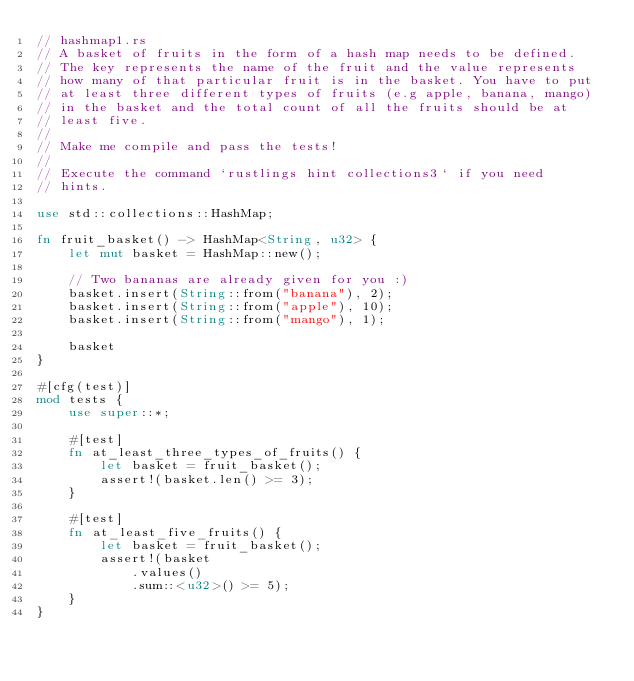Convert code to text. <code><loc_0><loc_0><loc_500><loc_500><_Rust_>// hashmap1.rs
// A basket of fruits in the form of a hash map needs to be defined.
// The key represents the name of the fruit and the value represents
// how many of that particular fruit is in the basket. You have to put
// at least three different types of fruits (e.g apple, banana, mango)
// in the basket and the total count of all the fruits should be at
// least five.
//
// Make me compile and pass the tests!
//
// Execute the command `rustlings hint collections3` if you need
// hints.

use std::collections::HashMap;

fn fruit_basket() -> HashMap<String, u32> {
    let mut basket = HashMap::new();

    // Two bananas are already given for you :)
    basket.insert(String::from("banana"), 2);
    basket.insert(String::from("apple"), 10);
    basket.insert(String::from("mango"), 1);

    basket
}

#[cfg(test)]
mod tests {
    use super::*;

    #[test]
    fn at_least_three_types_of_fruits() {
        let basket = fruit_basket();
        assert!(basket.len() >= 3);
    }

    #[test]
    fn at_least_five_fruits() {
        let basket = fruit_basket();
        assert!(basket
            .values()
            .sum::<u32>() >= 5);
    }
}
</code> 